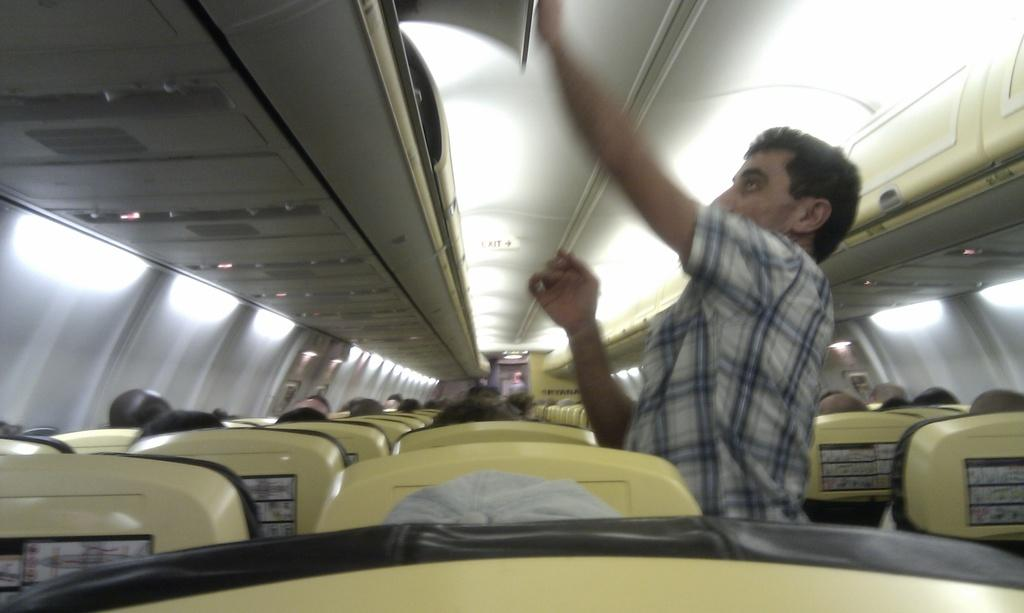What type of location is shown in the image? The image depicts the interior of an aeroplane. Can you describe the people in the image? There is a person standing in the image, and there are people sitting on chairs. What can be seen in terms of lighting in the image? There are lights visible in the image. What type of brass instrument is being played by the person standing in the image? There is no brass instrument present in the image; the person standing is not playing any instrument. How many turkeys can be seen in the image? There are no turkeys present in the image; it depicts the interior of an aeroplane. 